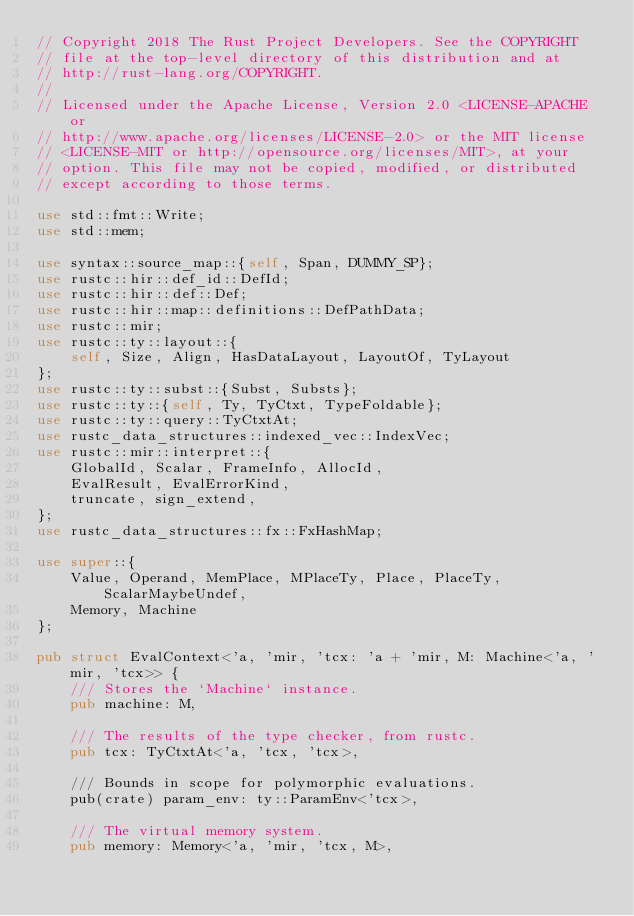Convert code to text. <code><loc_0><loc_0><loc_500><loc_500><_Rust_>// Copyright 2018 The Rust Project Developers. See the COPYRIGHT
// file at the top-level directory of this distribution and at
// http://rust-lang.org/COPYRIGHT.
//
// Licensed under the Apache License, Version 2.0 <LICENSE-APACHE or
// http://www.apache.org/licenses/LICENSE-2.0> or the MIT license
// <LICENSE-MIT or http://opensource.org/licenses/MIT>, at your
// option. This file may not be copied, modified, or distributed
// except according to those terms.

use std::fmt::Write;
use std::mem;

use syntax::source_map::{self, Span, DUMMY_SP};
use rustc::hir::def_id::DefId;
use rustc::hir::def::Def;
use rustc::hir::map::definitions::DefPathData;
use rustc::mir;
use rustc::ty::layout::{
    self, Size, Align, HasDataLayout, LayoutOf, TyLayout
};
use rustc::ty::subst::{Subst, Substs};
use rustc::ty::{self, Ty, TyCtxt, TypeFoldable};
use rustc::ty::query::TyCtxtAt;
use rustc_data_structures::indexed_vec::IndexVec;
use rustc::mir::interpret::{
    GlobalId, Scalar, FrameInfo, AllocId,
    EvalResult, EvalErrorKind,
    truncate, sign_extend,
};
use rustc_data_structures::fx::FxHashMap;

use super::{
    Value, Operand, MemPlace, MPlaceTy, Place, PlaceTy, ScalarMaybeUndef,
    Memory, Machine
};

pub struct EvalContext<'a, 'mir, 'tcx: 'a + 'mir, M: Machine<'a, 'mir, 'tcx>> {
    /// Stores the `Machine` instance.
    pub machine: M,

    /// The results of the type checker, from rustc.
    pub tcx: TyCtxtAt<'a, 'tcx, 'tcx>,

    /// Bounds in scope for polymorphic evaluations.
    pub(crate) param_env: ty::ParamEnv<'tcx>,

    /// The virtual memory system.
    pub memory: Memory<'a, 'mir, 'tcx, M>,
</code> 